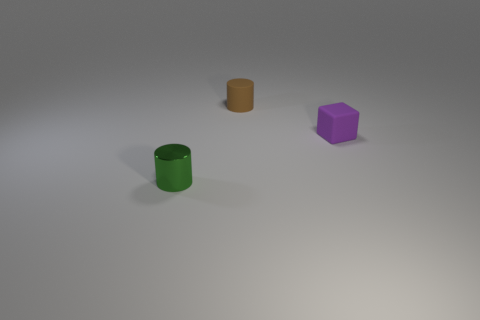There is a green cylinder that is to the left of the tiny rubber thing that is behind the small purple thing; is there a object on the right side of it?
Ensure brevity in your answer.  Yes. How many other objects are the same color as the matte block?
Offer a terse response. 0. What number of cylinders are both in front of the brown cylinder and right of the tiny green thing?
Provide a short and direct response. 0. What shape is the small metal object?
Give a very brief answer. Cylinder. How many other things are there of the same material as the purple object?
Your answer should be very brief. 1. There is a small cylinder that is right of the cylinder in front of the cylinder that is on the right side of the small shiny thing; what color is it?
Your response must be concise. Brown. There is a purple object that is the same size as the brown thing; what material is it?
Make the answer very short. Rubber. What number of objects are cylinders in front of the small brown matte object or cylinders?
Provide a succinct answer. 2. Are there any purple metal blocks?
Keep it short and to the point. No. There is a thing to the left of the brown object; what material is it?
Keep it short and to the point. Metal. 